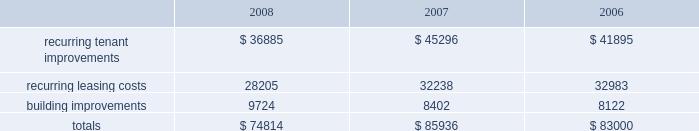Customary conditions .
We will retain a 20% ( 20 % ) equity interest in the joint venture .
As of december 31 , 2008 , the joint venture has acquired seven properties from us and we received year-to-date net sale proceeds and financing distributions of approximately $ 251.6 million .
In january 2008 , we sold a tract of land to an unconsolidated joint venture in which we hold a 50% ( 50 % ) equity interest and received a distribution , commensurate to our partner 2019s 50% ( 50 % ) ownership interest , of approximately $ 38.3 million .
In november 2008 , that unconsolidated joint venture entered a loan agreement with a consortium of banks and distributed a portion of the loan proceeds to us and our partner , with our share of the distribution totaling $ 20.4 million .
Uses of liquidity our principal uses of liquidity include the following : 2022 property investment ; 2022 recurring leasing/capital costs ; 2022 dividends and distributions to shareholders and unitholders ; 2022 long-term debt maturities ; 2022 opportunistic repurchases of outstanding debt ; and 2022 other contractual obligations .
Property investment we evaluate development and acquisition opportunities based upon market outlook , supply and long-term growth potential .
Our ability to make future property investments is dependent upon our continued access to our longer-term sources of liquidity including the issuances of debt or equity securities as well as disposing of selected properties .
In light of current economic conditions , management continues to evaluate our investment priorities and we are limiting new development expenditures .
Recurring expenditures one of our principal uses of our liquidity is to fund the recurring leasing/capital expenditures of our real estate investments .
The following is a summary of our recurring capital expenditures for the years ended december 31 , 2008 , 2007 and 2006 , respectively ( in thousands ) : .
Dividends and distributions in order to qualify as a reit for federal income tax purposes , we must currently distribute at least 90% ( 90 % ) of our taxable income to shareholders .
Because depreciation is a non-cash expense , cash flow will typically be greater than operating income .
We paid dividends per share of $ 1.93 , $ 1.91 and $ 1.89 for the years ended december 31 , 2008 , 2007 and 2006 , respectively .
We expect to continue to distribute taxable earnings to meet the requirements to maintain our reit status .
However , distributions are declared at the discretion of our board of directors and are subject to actual cash available for distribution , our financial condition , capital requirements and such other factors as our board of directors deems relevant . in january 2009 , our board of directors resolved to decrease our annual dividend from $ 1.94 per share to $ 1.00 per share in order to retain additional cash to help meet our capital needs .
We anticipate retaining additional cash of approximately $ 145.2 million per year , when compared to an annual dividend of $ 1.94 per share , as the result of this action .
At december 31 , 2008 we had six series of preferred shares outstanding .
The annual dividend rates on our preferred shares range between 6.5% ( 6.5 % ) and 8.375% ( 8.375 % ) and are paid in arrears quarterly. .
What was the average dividend per share from 2006 to 2008 in dollars per share? 
Computations: (((1.93 + 1.91) + 1.89) / 3)
Answer: 1.91. 